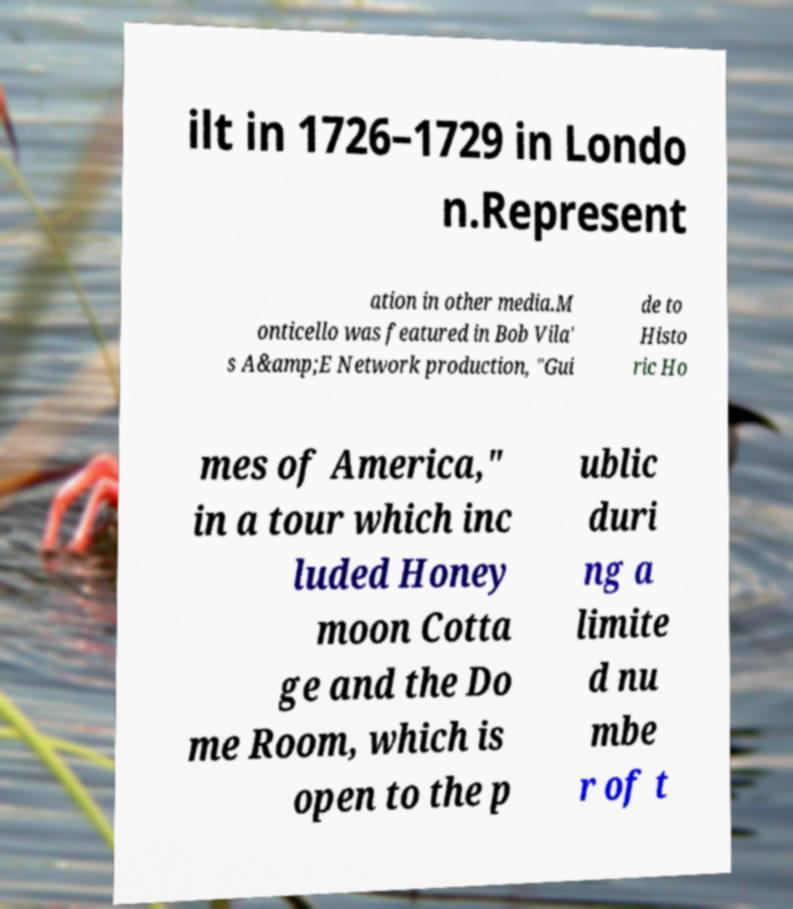Could you extract and type out the text from this image? ilt in 1726–1729 in Londo n.Represent ation in other media.M onticello was featured in Bob Vila' s A&amp;E Network production, "Gui de to Histo ric Ho mes of America," in a tour which inc luded Honey moon Cotta ge and the Do me Room, which is open to the p ublic duri ng a limite d nu mbe r of t 